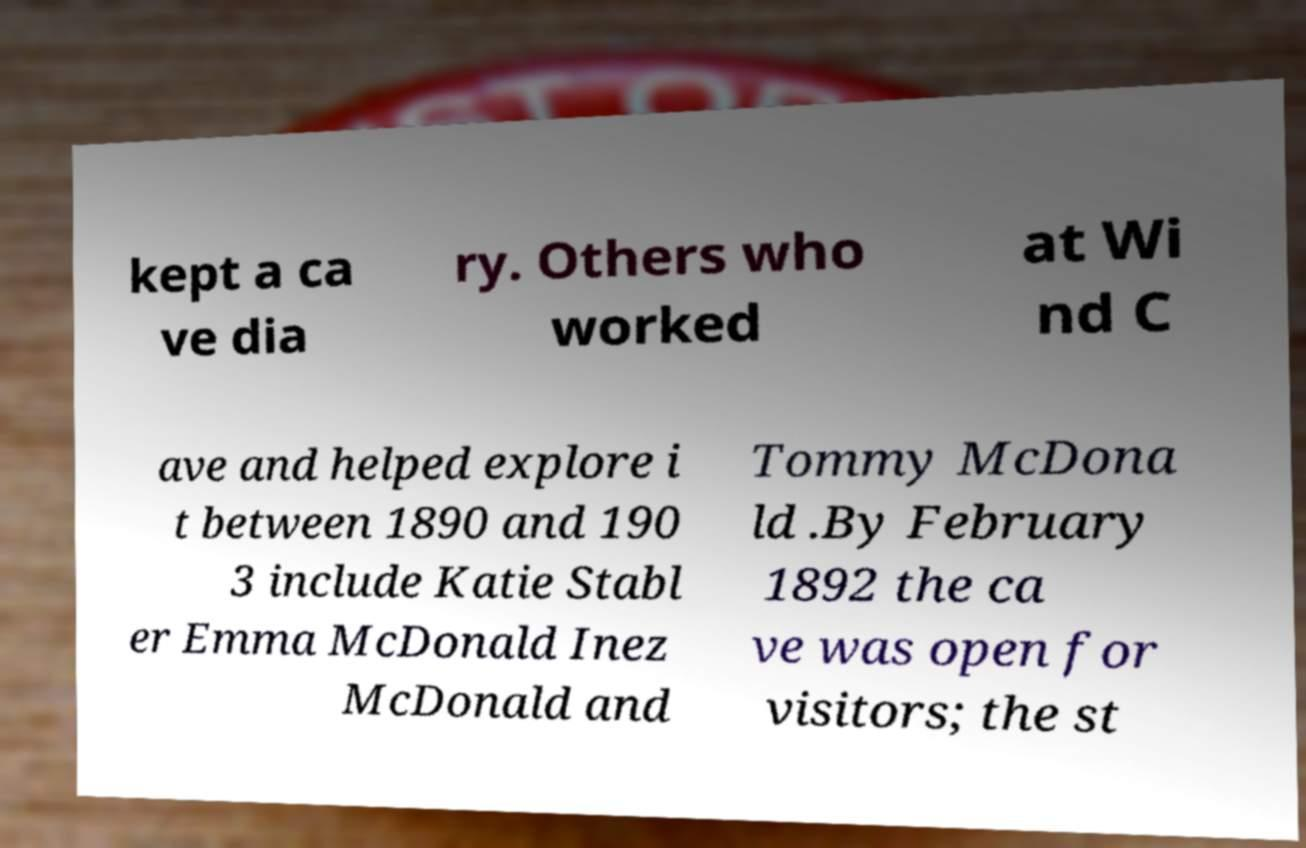For documentation purposes, I need the text within this image transcribed. Could you provide that? kept a ca ve dia ry. Others who worked at Wi nd C ave and helped explore i t between 1890 and 190 3 include Katie Stabl er Emma McDonald Inez McDonald and Tommy McDona ld .By February 1892 the ca ve was open for visitors; the st 